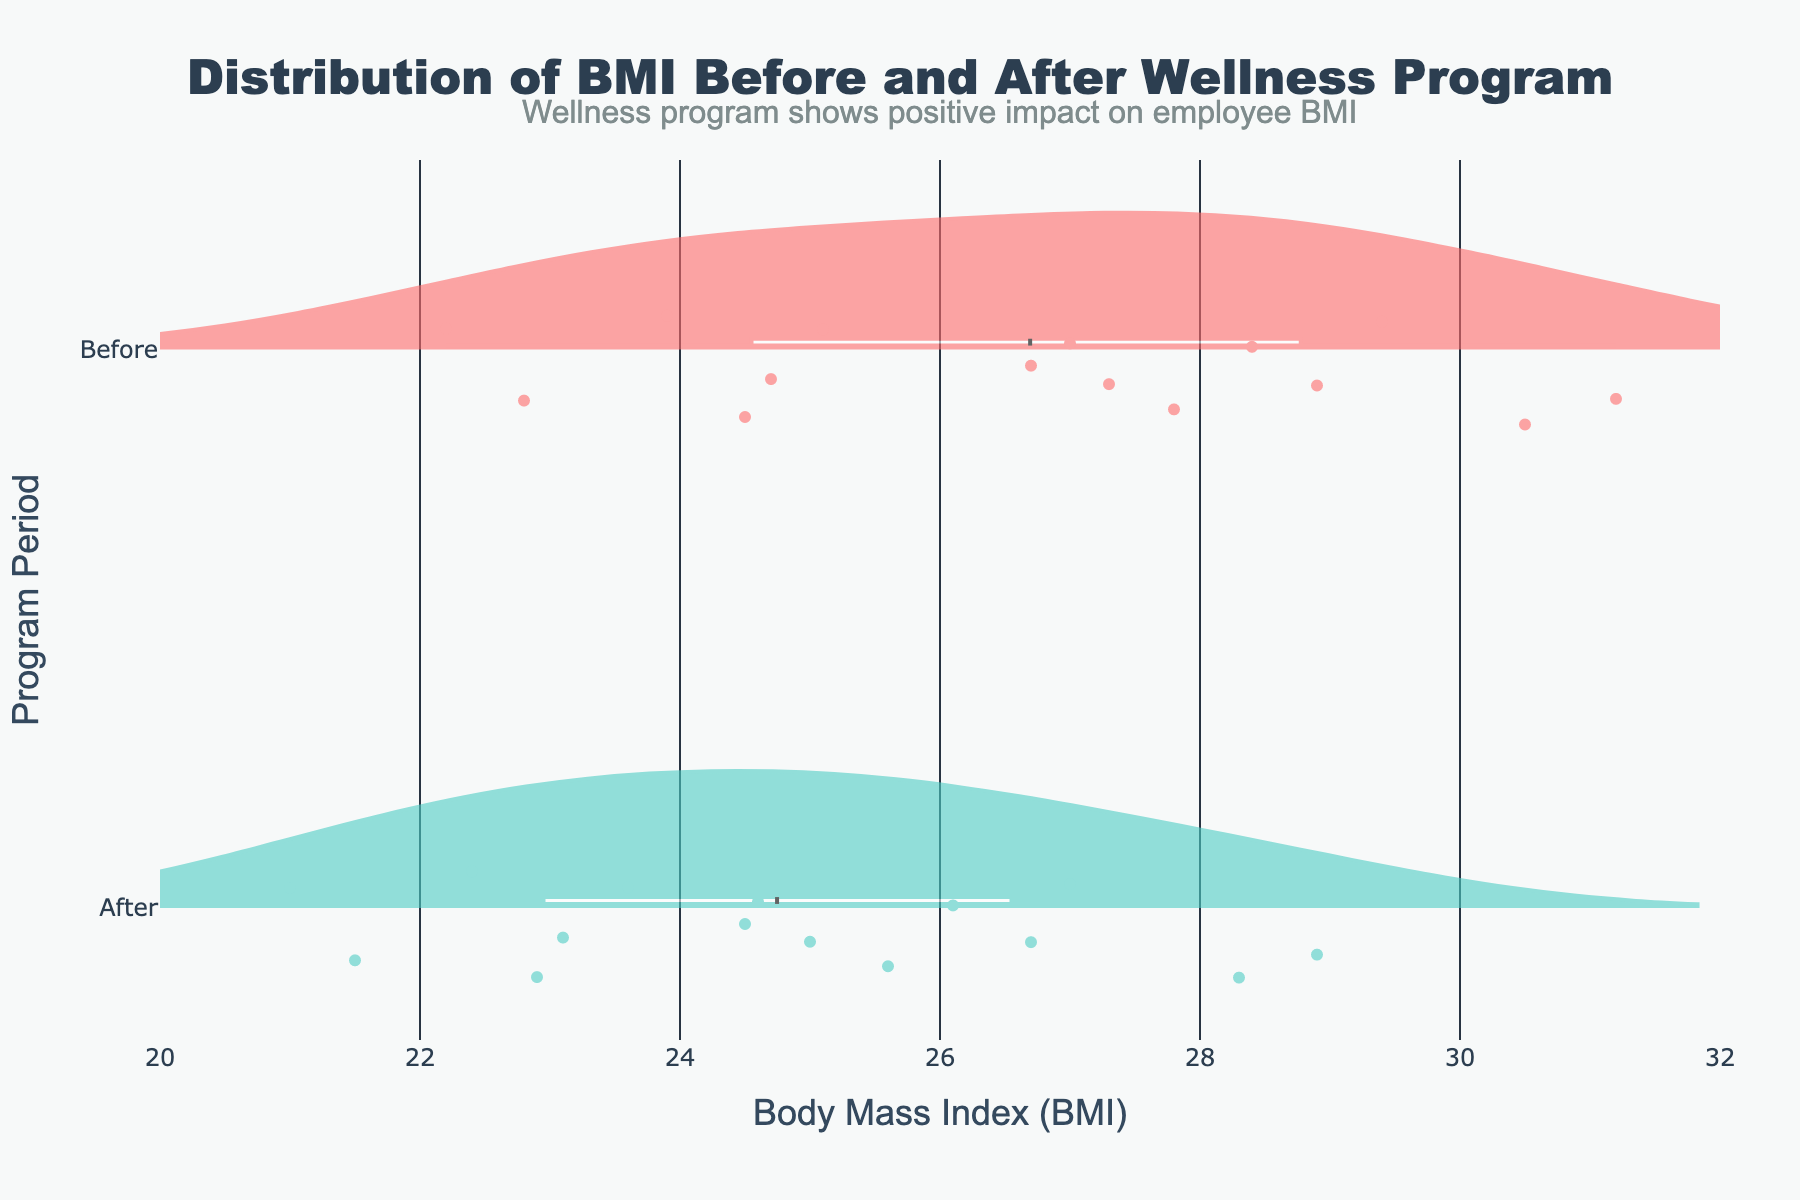What's the title of the figure? The title of the figure is located at the top center of the plot. By reading it, we can see it states "Distribution of BMI Before and After Wellness Program".
Answer: Distribution of BMI Before and After Wellness Program What are the two periods compared in the plot? The y-axis of the plot shows two categories, which are "Before" and "After". These represent the two periods compared in terms of BMI distribution.
Answer: Before and After What color represents the "Before" period? The violins are color-coded. The violin plot for the "Before" period is colored in red (#FF6B6B), indicating the BMI distribution before the wellness program.
Answer: Red Which period shows a higher average BMI? Both violins have average (mean) lines marked, with "Before" period's mean BMI appearing higher compared to the "After" period.
Answer: Before How does the distribution of BMI change from "Before" to "After"? By comparing the width and spread of the violins, we can see that the distribution of BMI values has shifted to a lower range after the wellness program. The "After" violin is generally shifted leftwards compared to the "Before" violin, indicating a reduction in BMI values.
Answer: Shifted leftwards What is the approximate mean BMI value in the "Before" period? The mean line is marked on the "Before" violin plot. Visually estimating from the x-axis, the mean BMI before the wellness program is approximately around 27 - 28.
Answer: Around 27 - 28 What is the BMI range of the employees after the wellness program? Looking at the spread of the "After" violin, the BMI values range approximately between 21 and 29. This can be inferred from where the violin starts and ends on the x-axis.
Answer: 21 to 29 Is there any overlap in BMI values between the "Before" and "After" periods? By analyzing the overlap of the two violins on the x-axis, we can see some common values between 21 to 29, indicating overlap in BMI values before and after the program.
Answer: Yes What's the maximum BMI value recorded in the "Before" period? The furthest right point of the "Before" violin indicates the maximum BMI value, which is approximately 31.
Answer: 31 How does the median BMI value compare between the "Before" and "After" periods? The median is represented by the thick line within the violin plots. The median in the "Before" period is higher compared to the median in the "After" period. By visual inspection, the median for "Before" is around 27, whereas for "After" it is around 24.
Answer: Higher in "Before" period 